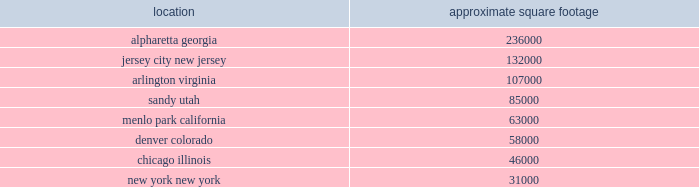Item a01b .
Unresolved staff comments e*trade 2018 10-k | page 24 item a02 .
Properties a summary of our significant locations at december a031 , 2018 is shown in the table .
Square footage amounts are net of space that has been sublet or space that is part of a facility restructuring. .
All facilities are leased at december a031 , 2018 .
All other leased facilities with space of less than 25000 square feet are not listed by location .
In addition to the significant facilities above , we also lease all 30 regional financial centers , ranging in space from approximately 2500 to 8000 square feet .
Item a03 .
Legal proceedings information in response to this item can be found under the heading litigation matters in note 21 2014 commitments , contingencies and other regulatory matters in this annual report and is incorporated by reference into this item .
Item 4 .
Mine safety disclosures not applicable. .
What is the ratio of the square footage in alpharetta georgia to jersey city new jersey as of december 2018? 
Rationale: the ratio of the square footage in alpharetta georgia to jersey city new jersey as of december 2018 was 1.79 to 1
Computations: (236000 / 132000)
Answer: 1.78788. 